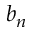Convert formula to latex. <formula><loc_0><loc_0><loc_500><loc_500>b _ { n }</formula> 